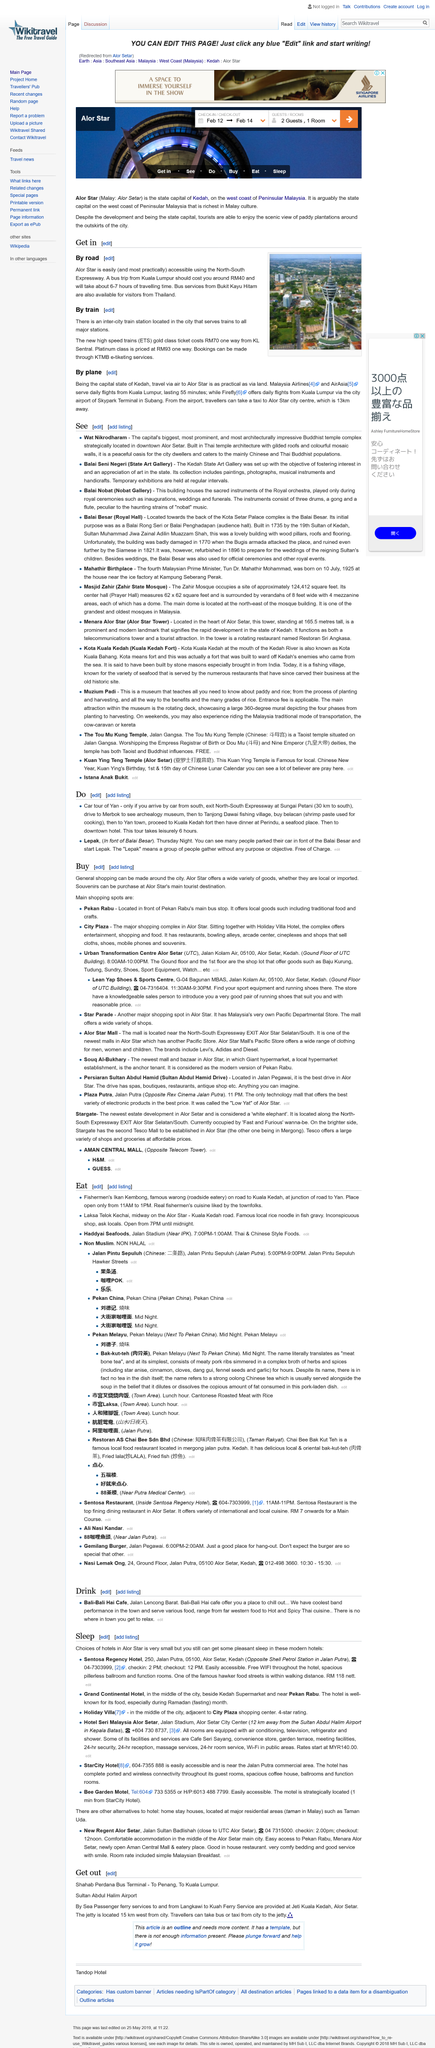Identify some key points in this picture. It is possible to stay at the Sentosa Regency Hotel while in Alor Star. Bookings for the high speed trains are made through the KTMB e-tiketing services. Yes, Kuala Lumpur has high speed trains. Alor Star is most practically accessible by road using the North-South Expressway. On a Thursday, it is possible to park one's car for free in front of the Balai Besar for a duration of six hours, during which a car tour of Yan can be taken. 